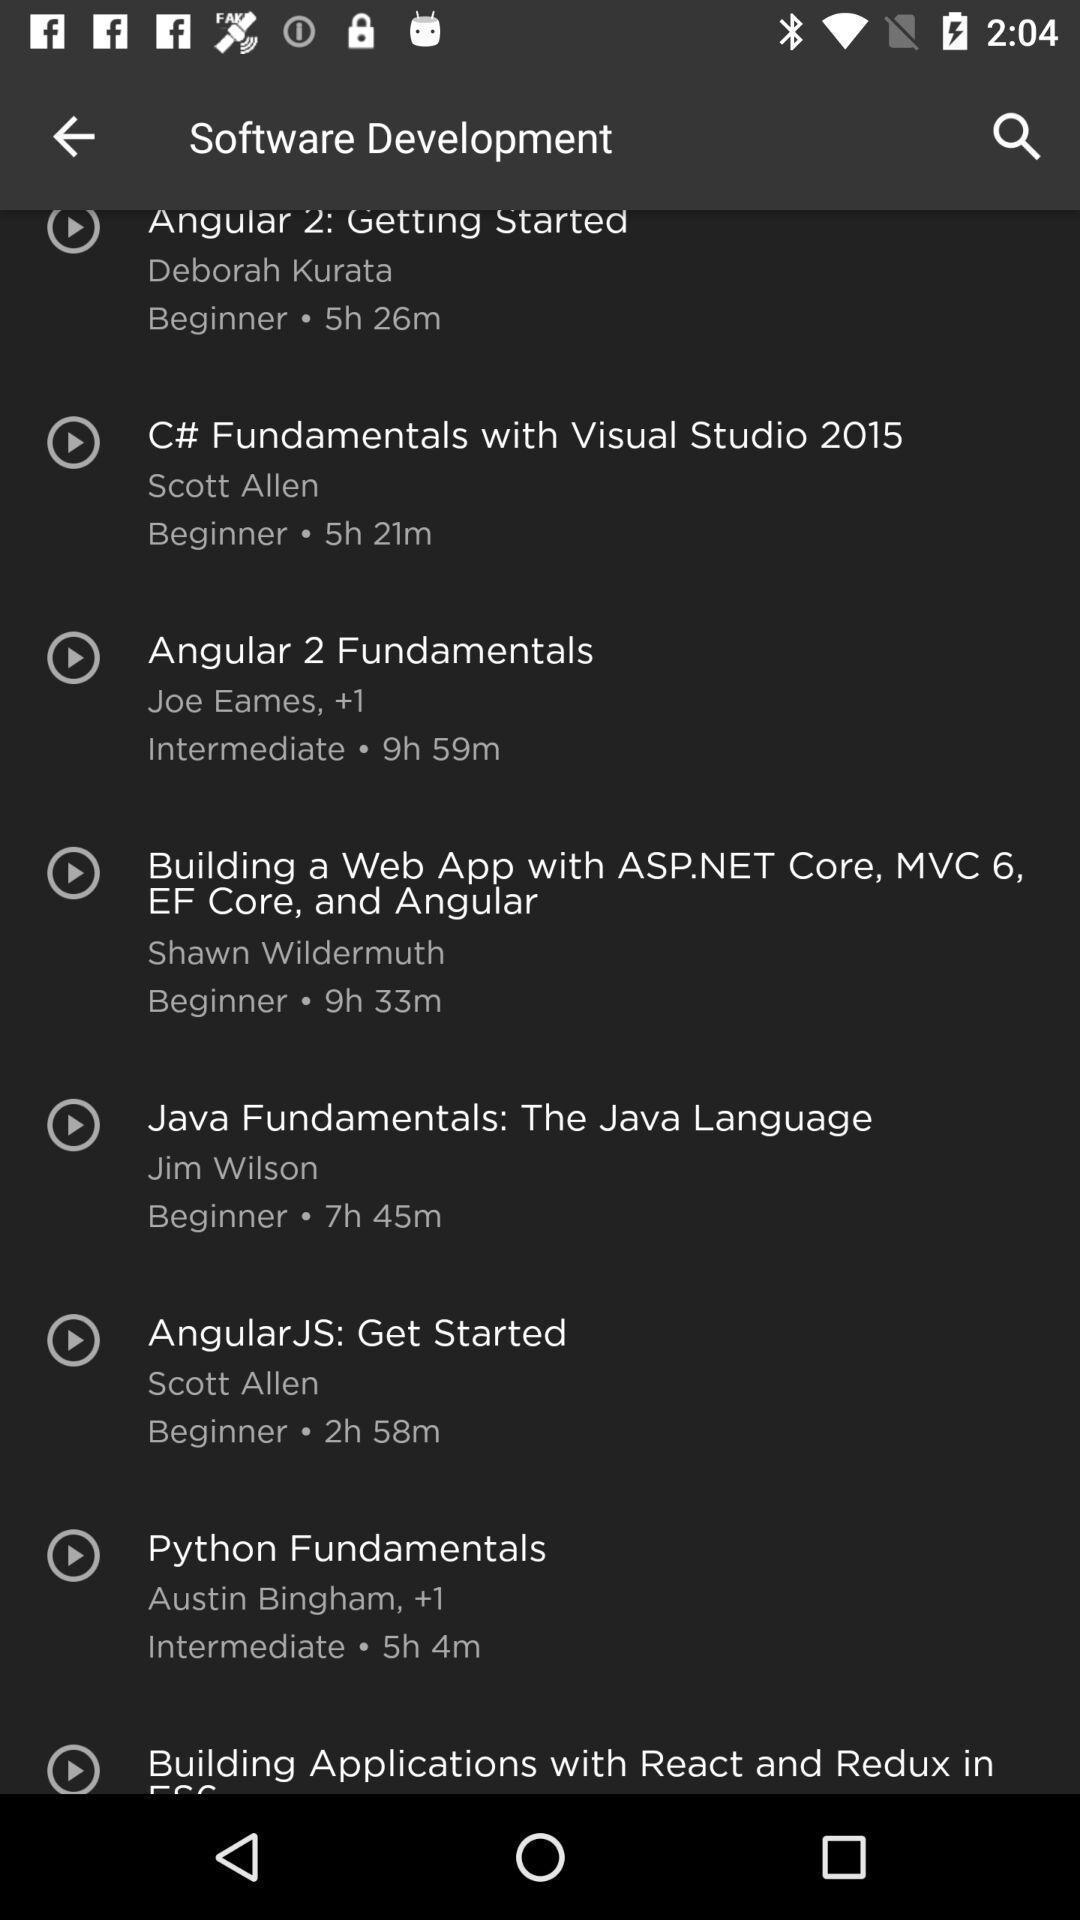Please provide a description for this image. Page that shows various learning options. 